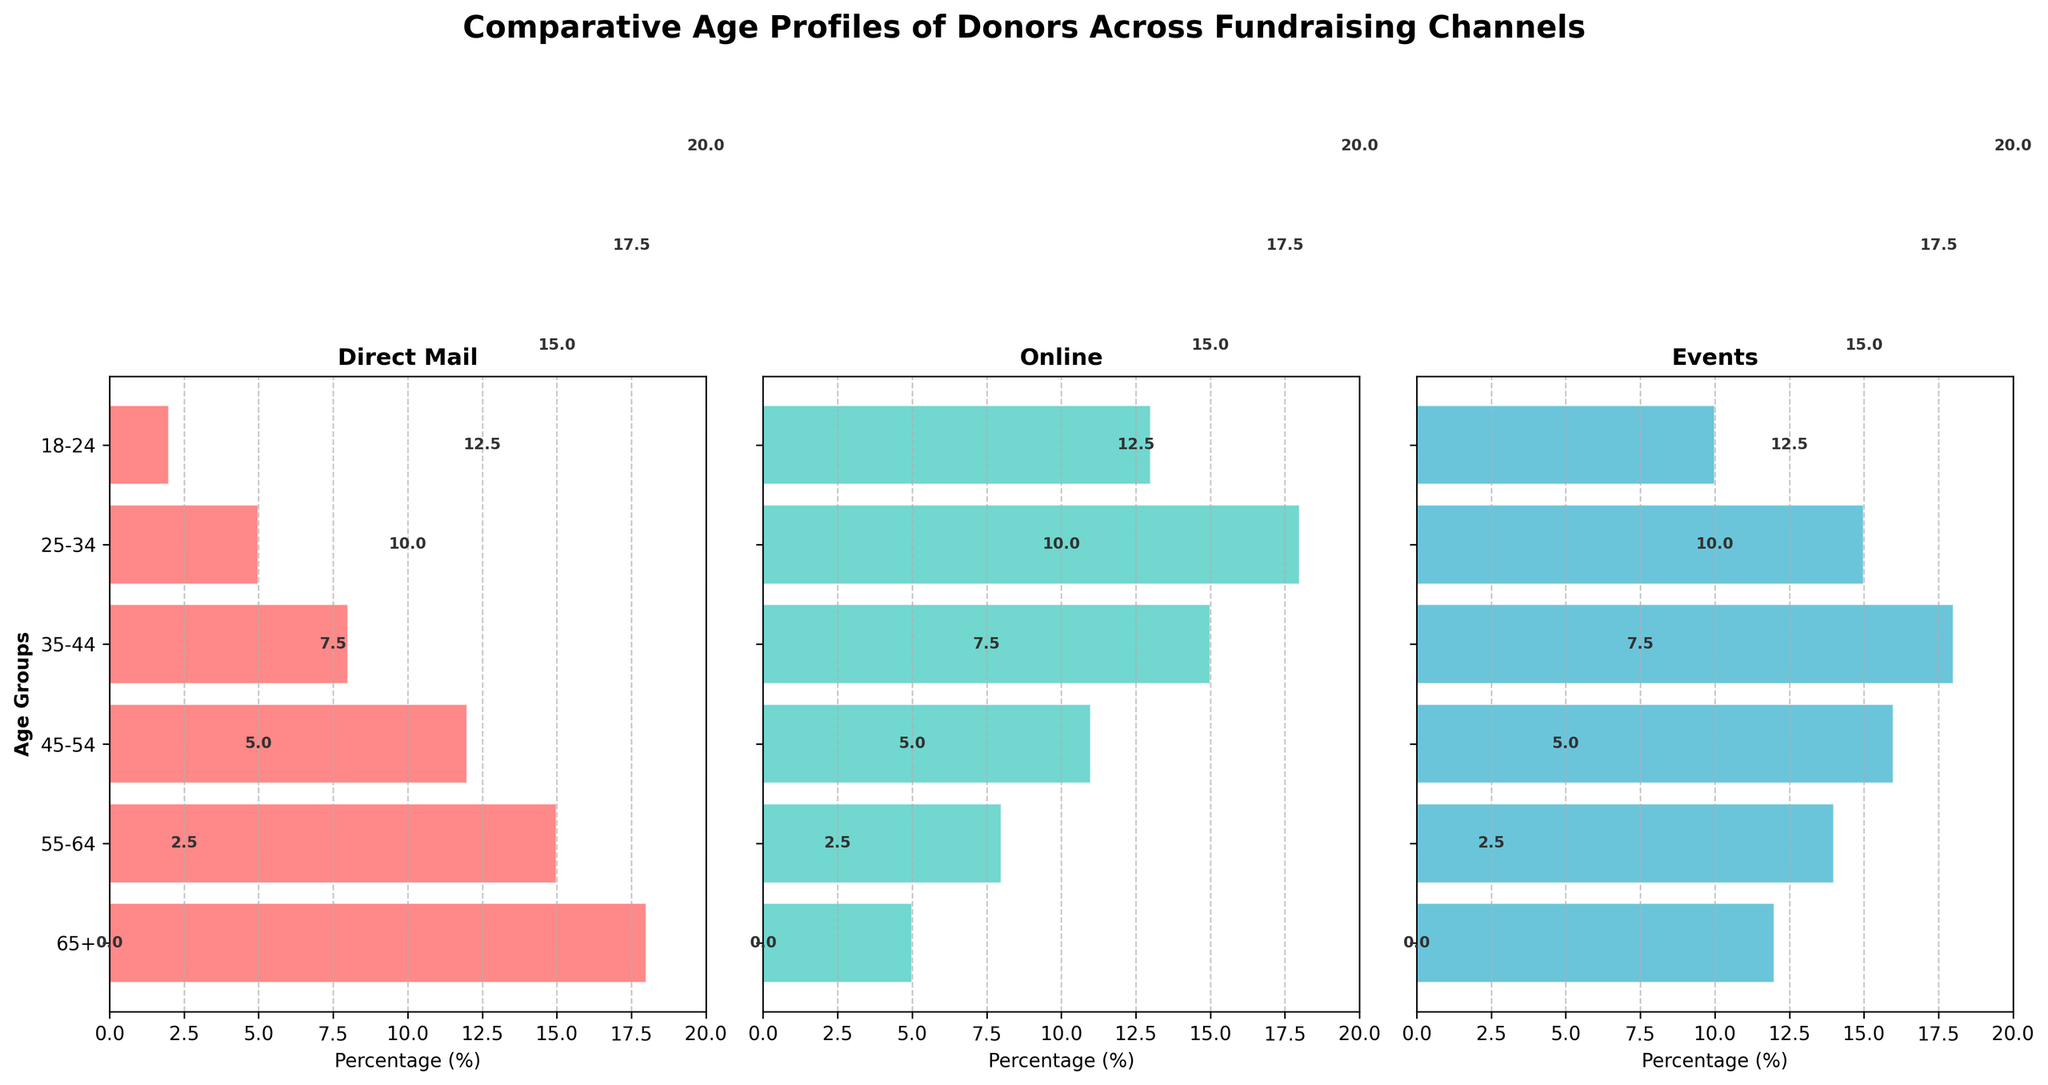What is the title of the figure? The title is found at the top center of the figure, indicating the overall subject of the plot.
Answer: Comparative Age Profiles of Donors Across Fundraising Channels Which fundraising channel has the highest percentage of donors aged 35-44? By looking at the bar heights for the 35-44 age group in each channel, we can compare the values.
Answer: Events What age group has the fewest donors in the direct mail channel? The shortest bar in the direct mail section corresponds to the age group with the fewest donors.
Answer: 18-24 What's the total percentage of donors aged 55-64 across all channels? Sum the percentages for the 55-64 age group from all three channels: 15 (Direct Mail) + 8 (Online) + 14 (Events). The total is 37.
Answer: 37 Which age group has the widest disparity in donor percentage between the direct mail and online channels? Calculate the absolute difference in percentages for each age group between direct mail and online, then identify the one with the largest difference.
Answer: 65+ How does the donor distribution in the 25-34 age group compare across the channels? By examining the bars for the 25-34 age group in each channel, compare their heights. The donor percentages for 25-34 are 5 (Direct Mail), 18 (Online), and 15 (Events). Online has the highest, followed by Events, then Direct Mail.
Answer: Online > Events > Direct Mail Which channel attracts the most young donors (18-24)? Look at the bars for the 18-24 age group in each channel and compare their heights.
Answer: Online For the 45-54 age group, how many more donors are there in events than in direct mail? Subtract the percentage of donors in direct mail (12) from the percentage of donors in events (16).
Answer: 4 Which age group is consistently high across all channels? Identify the age group that has relatively high percentages in all three channels. The 35-44 age group has 8 (Direct Mail), 15 (Online), and 18 (Events).
Answer: 35-44 What's the average percentage of donors aged 65+ across all channels? Add the percentages for the 65+ age group and divide by the number of channels: (18 + 5 + 12) / 3. The average is 11.67.
Answer: 11.67 